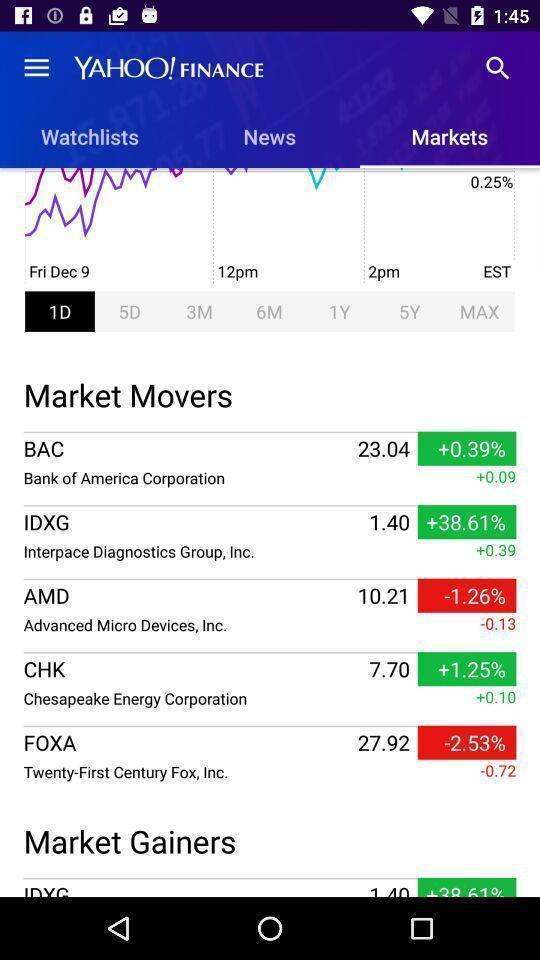Summarize the main components in this picture. Screen displaying multiple options and information about stock market. 